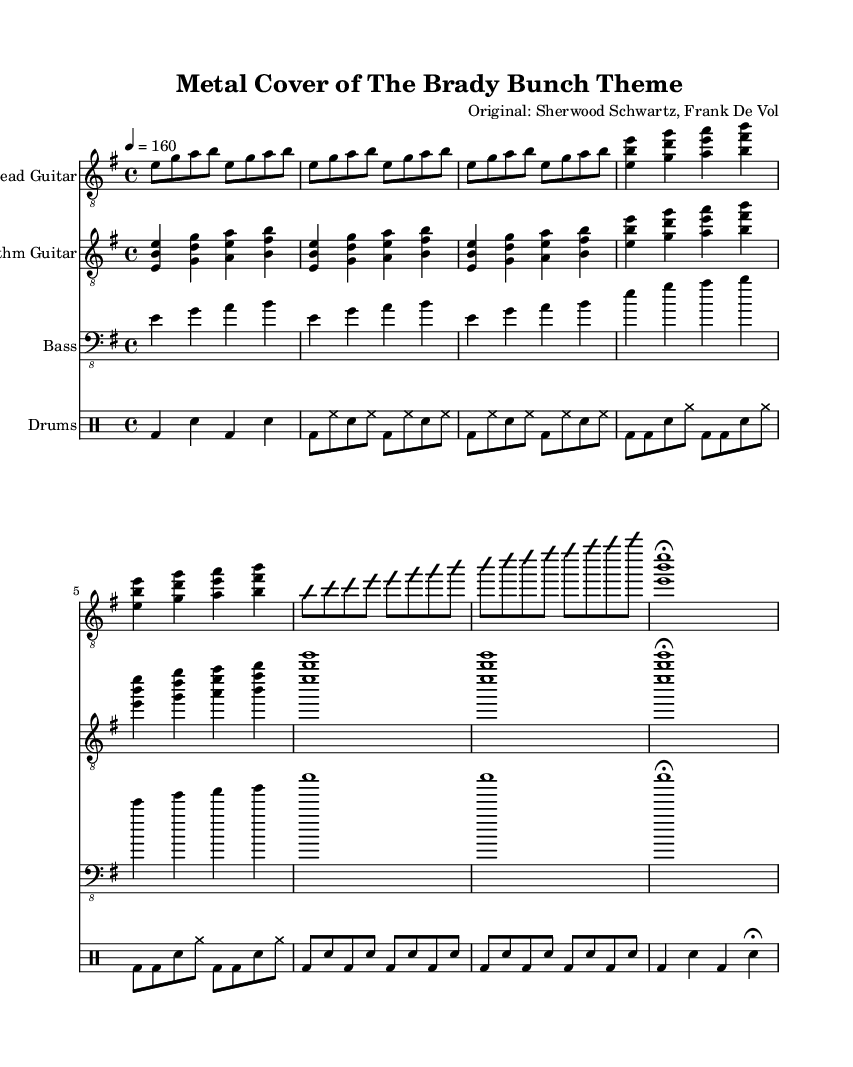What is the key signature of this music? The key signature is E minor, which has one sharp (F#). The presence of one sharp indicates that the piece is in E minor.
Answer: E minor What is the time signature of this music? The time signature is 4/4, meaning there are four beats in each measure. This is indicated at the start of the score where the time signature is noted as 4/4.
Answer: 4/4 What is the tempo marking for this music? The tempo marking is indicated as 4 = 160, meaning there are 160 beats per minute. This denotes a fast tempo typical for metal covers.
Answer: 160 How many measures are there in the chorus section? By counting the measures in the chorus part of the score, we can see that there are 4 measures. Each of these measures has a distinct grouping of notes that defines the chorus.
Answer: 4 What type of guitar is primarily used in the melody? The electric guitar is specified for the melody part in the score. This is indicated by the labeling in the score and the style of the written notes, which suit electric guitar playing.
Answer: Electric guitar How many instruments are included in this piece? The score indicates a total of four instruments: Lead Guitar, Rhythm Guitar, Bass, and Drums. Each is clearly labeled in the score layout.
Answer: Four What style is this arrangement representative of? The arrangement is a metal cover, as indicated by the style of the music and the instrumentation typically used in metal genres, such as heavy electric guitars and powerful drums.
Answer: Metal 